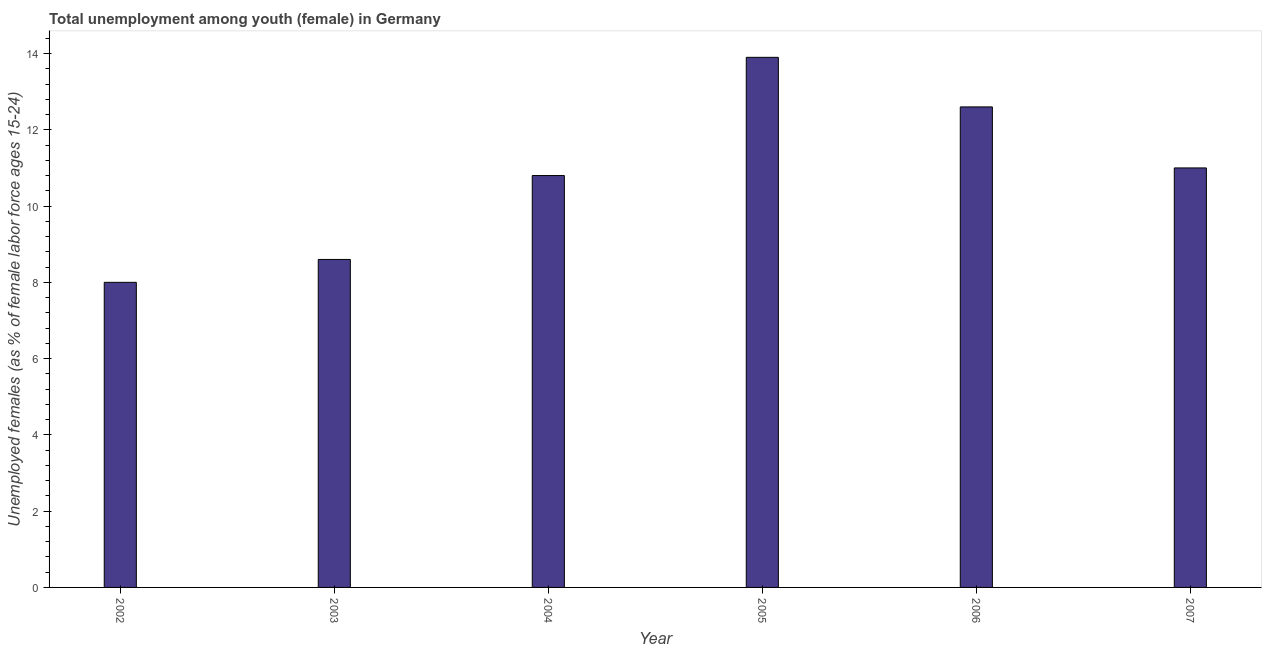Does the graph contain any zero values?
Your response must be concise. No. Does the graph contain grids?
Provide a short and direct response. No. What is the title of the graph?
Keep it short and to the point. Total unemployment among youth (female) in Germany. What is the label or title of the Y-axis?
Ensure brevity in your answer.  Unemployed females (as % of female labor force ages 15-24). What is the unemployed female youth population in 2006?
Provide a short and direct response. 12.6. Across all years, what is the maximum unemployed female youth population?
Your answer should be very brief. 13.9. Across all years, what is the minimum unemployed female youth population?
Ensure brevity in your answer.  8. What is the sum of the unemployed female youth population?
Offer a terse response. 64.9. What is the difference between the unemployed female youth population in 2002 and 2004?
Your answer should be compact. -2.8. What is the average unemployed female youth population per year?
Provide a short and direct response. 10.82. What is the median unemployed female youth population?
Your answer should be very brief. 10.9. In how many years, is the unemployed female youth population greater than 1.2 %?
Your answer should be compact. 6. Do a majority of the years between 2007 and 2005 (inclusive) have unemployed female youth population greater than 5.2 %?
Give a very brief answer. Yes. What is the ratio of the unemployed female youth population in 2002 to that in 2005?
Offer a very short reply. 0.58. Is the unemployed female youth population in 2002 less than that in 2004?
Your response must be concise. Yes. In how many years, is the unemployed female youth population greater than the average unemployed female youth population taken over all years?
Keep it short and to the point. 3. Are all the bars in the graph horizontal?
Provide a short and direct response. No. How many years are there in the graph?
Provide a short and direct response. 6. What is the Unemployed females (as % of female labor force ages 15-24) of 2002?
Your response must be concise. 8. What is the Unemployed females (as % of female labor force ages 15-24) in 2003?
Keep it short and to the point. 8.6. What is the Unemployed females (as % of female labor force ages 15-24) in 2004?
Ensure brevity in your answer.  10.8. What is the Unemployed females (as % of female labor force ages 15-24) in 2005?
Offer a very short reply. 13.9. What is the Unemployed females (as % of female labor force ages 15-24) in 2006?
Keep it short and to the point. 12.6. What is the difference between the Unemployed females (as % of female labor force ages 15-24) in 2002 and 2003?
Offer a very short reply. -0.6. What is the difference between the Unemployed females (as % of female labor force ages 15-24) in 2002 and 2004?
Your response must be concise. -2.8. What is the difference between the Unemployed females (as % of female labor force ages 15-24) in 2003 and 2004?
Your response must be concise. -2.2. What is the difference between the Unemployed females (as % of female labor force ages 15-24) in 2003 and 2005?
Provide a short and direct response. -5.3. What is the difference between the Unemployed females (as % of female labor force ages 15-24) in 2003 and 2006?
Your response must be concise. -4. What is the difference between the Unemployed females (as % of female labor force ages 15-24) in 2004 and 2006?
Your answer should be compact. -1.8. What is the ratio of the Unemployed females (as % of female labor force ages 15-24) in 2002 to that in 2003?
Offer a very short reply. 0.93. What is the ratio of the Unemployed females (as % of female labor force ages 15-24) in 2002 to that in 2004?
Offer a terse response. 0.74. What is the ratio of the Unemployed females (as % of female labor force ages 15-24) in 2002 to that in 2005?
Your answer should be very brief. 0.58. What is the ratio of the Unemployed females (as % of female labor force ages 15-24) in 2002 to that in 2006?
Your answer should be compact. 0.64. What is the ratio of the Unemployed females (as % of female labor force ages 15-24) in 2002 to that in 2007?
Make the answer very short. 0.73. What is the ratio of the Unemployed females (as % of female labor force ages 15-24) in 2003 to that in 2004?
Ensure brevity in your answer.  0.8. What is the ratio of the Unemployed females (as % of female labor force ages 15-24) in 2003 to that in 2005?
Ensure brevity in your answer.  0.62. What is the ratio of the Unemployed females (as % of female labor force ages 15-24) in 2003 to that in 2006?
Your answer should be compact. 0.68. What is the ratio of the Unemployed females (as % of female labor force ages 15-24) in 2003 to that in 2007?
Your answer should be compact. 0.78. What is the ratio of the Unemployed females (as % of female labor force ages 15-24) in 2004 to that in 2005?
Give a very brief answer. 0.78. What is the ratio of the Unemployed females (as % of female labor force ages 15-24) in 2004 to that in 2006?
Offer a very short reply. 0.86. What is the ratio of the Unemployed females (as % of female labor force ages 15-24) in 2005 to that in 2006?
Your response must be concise. 1.1. What is the ratio of the Unemployed females (as % of female labor force ages 15-24) in 2005 to that in 2007?
Your answer should be compact. 1.26. What is the ratio of the Unemployed females (as % of female labor force ages 15-24) in 2006 to that in 2007?
Provide a succinct answer. 1.15. 